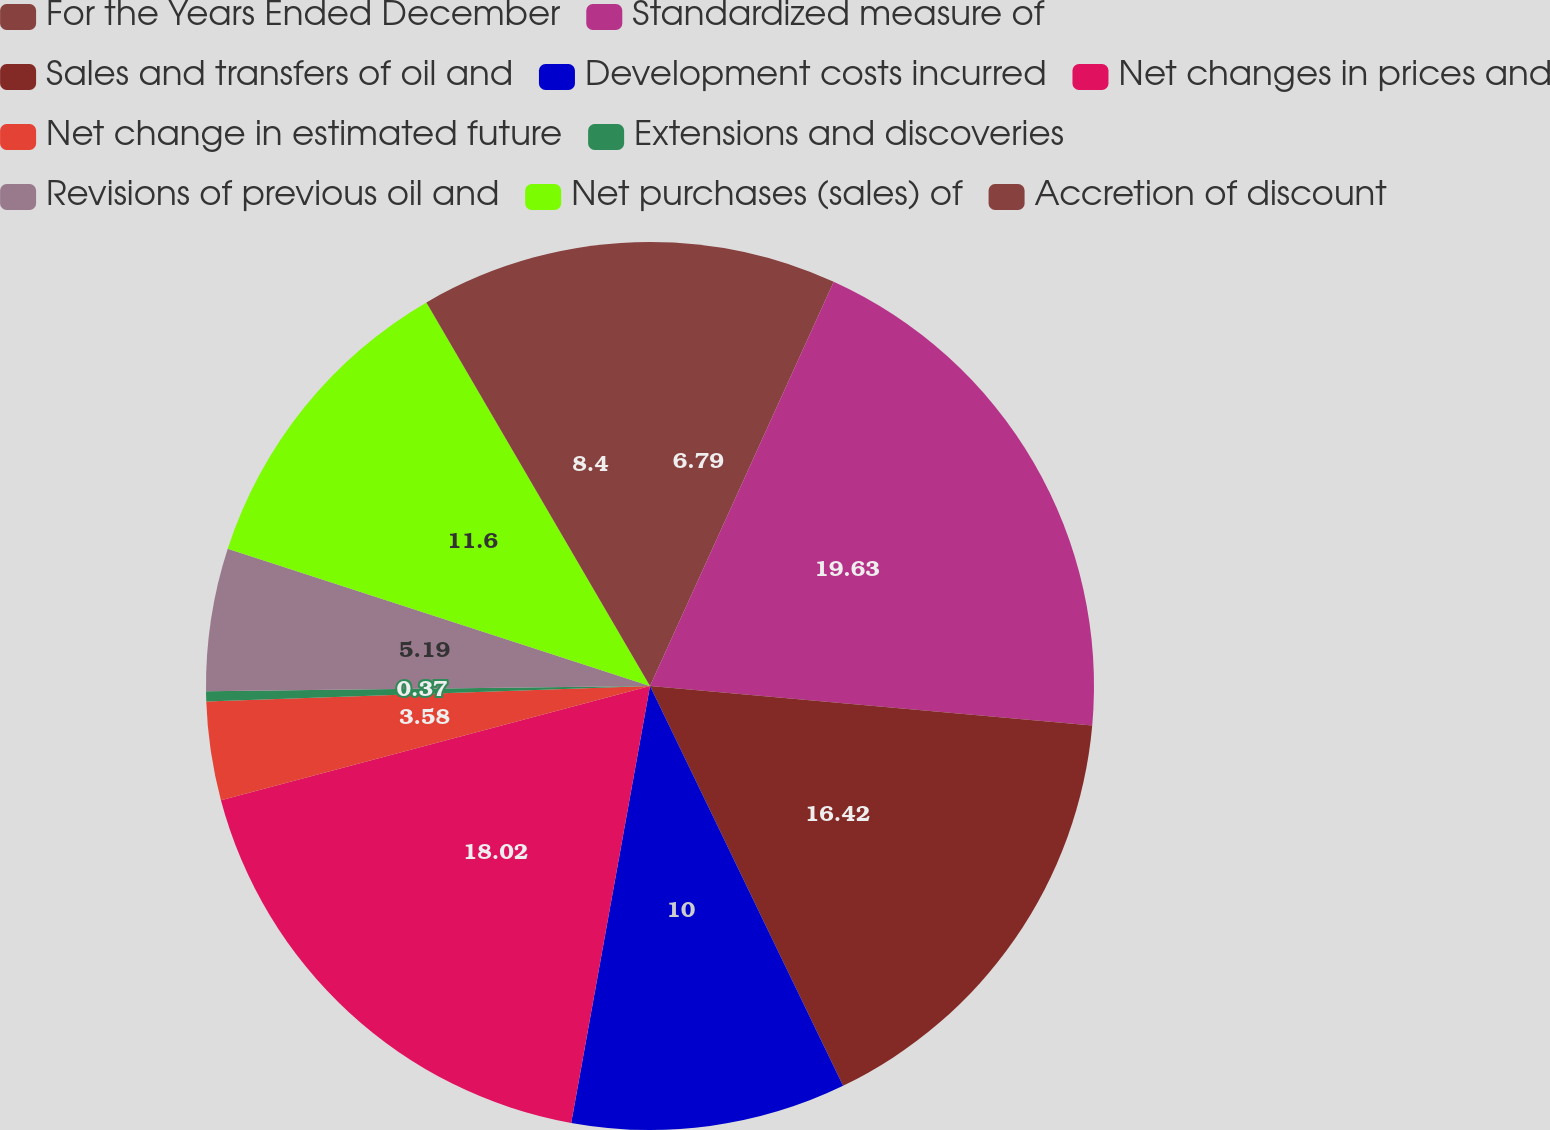Convert chart. <chart><loc_0><loc_0><loc_500><loc_500><pie_chart><fcel>For the Years Ended December<fcel>Standardized measure of<fcel>Sales and transfers of oil and<fcel>Development costs incurred<fcel>Net changes in prices and<fcel>Net change in estimated future<fcel>Extensions and discoveries<fcel>Revisions of previous oil and<fcel>Net purchases (sales) of<fcel>Accretion of discount<nl><fcel>6.79%<fcel>19.63%<fcel>16.42%<fcel>10.0%<fcel>18.02%<fcel>3.58%<fcel>0.37%<fcel>5.19%<fcel>11.6%<fcel>8.4%<nl></chart> 